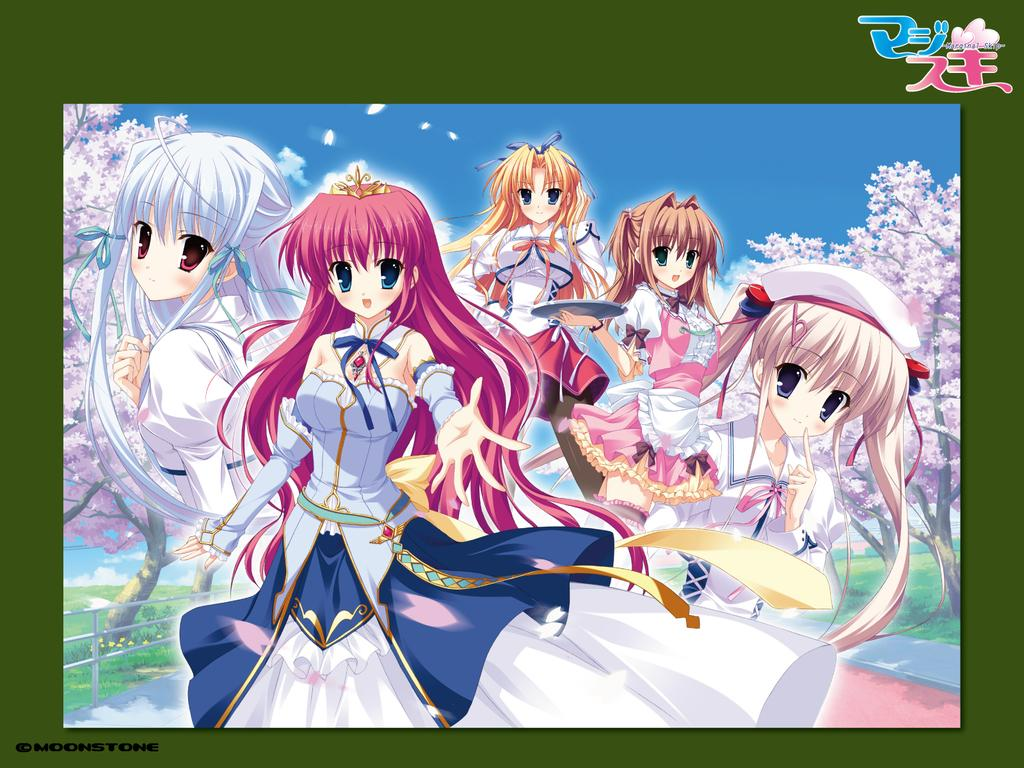How many girls are in the image? There are five girls in the image. What is a common feature among all the girls in the image? All the girls have long hair. Which girl stands out in the image? One girl is wearing a crown and a colorful dress. What is a unique feature of the girl wearing the crown? The girl with the crown has blue eyes. What can be seen in the background of the image? The sky is visible in the image and is blue in color, and there are trees in the image, which are white in color. What type of knowledge can be gained from touching the trees in the image? There is no need to touch the trees in the image to gain knowledge, as the image only provides visual information. 